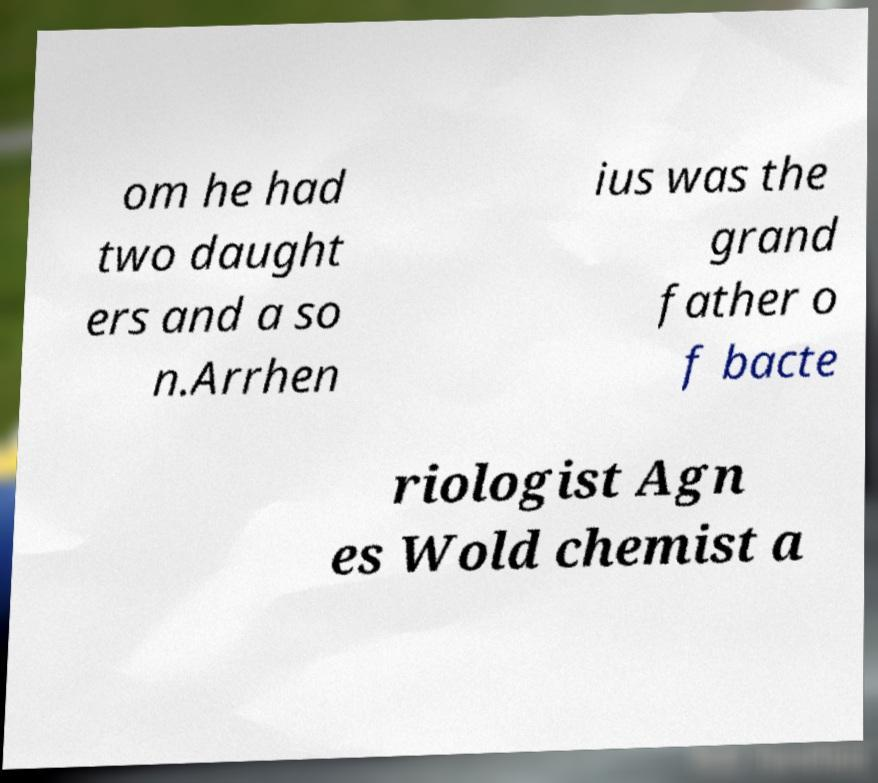Could you extract and type out the text from this image? om he had two daught ers and a so n.Arrhen ius was the grand father o f bacte riologist Agn es Wold chemist a 